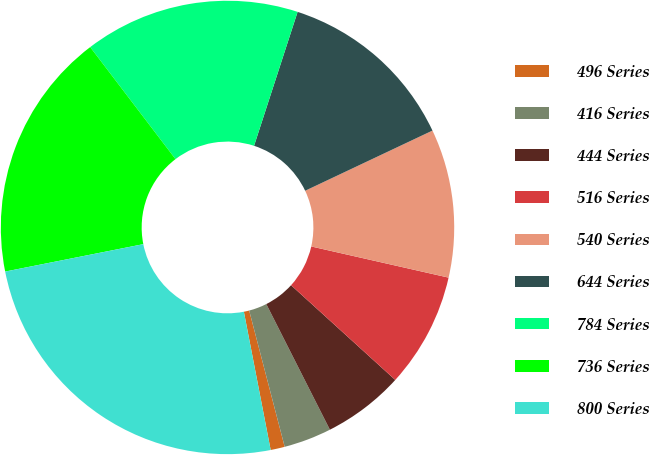Convert chart. <chart><loc_0><loc_0><loc_500><loc_500><pie_chart><fcel>496 Series<fcel>416 Series<fcel>444 Series<fcel>516 Series<fcel>540 Series<fcel>644 Series<fcel>784 Series<fcel>736 Series<fcel>800 Series<nl><fcel>1.01%<fcel>3.4%<fcel>5.8%<fcel>8.19%<fcel>10.58%<fcel>12.97%<fcel>15.36%<fcel>17.76%<fcel>24.93%<nl></chart> 